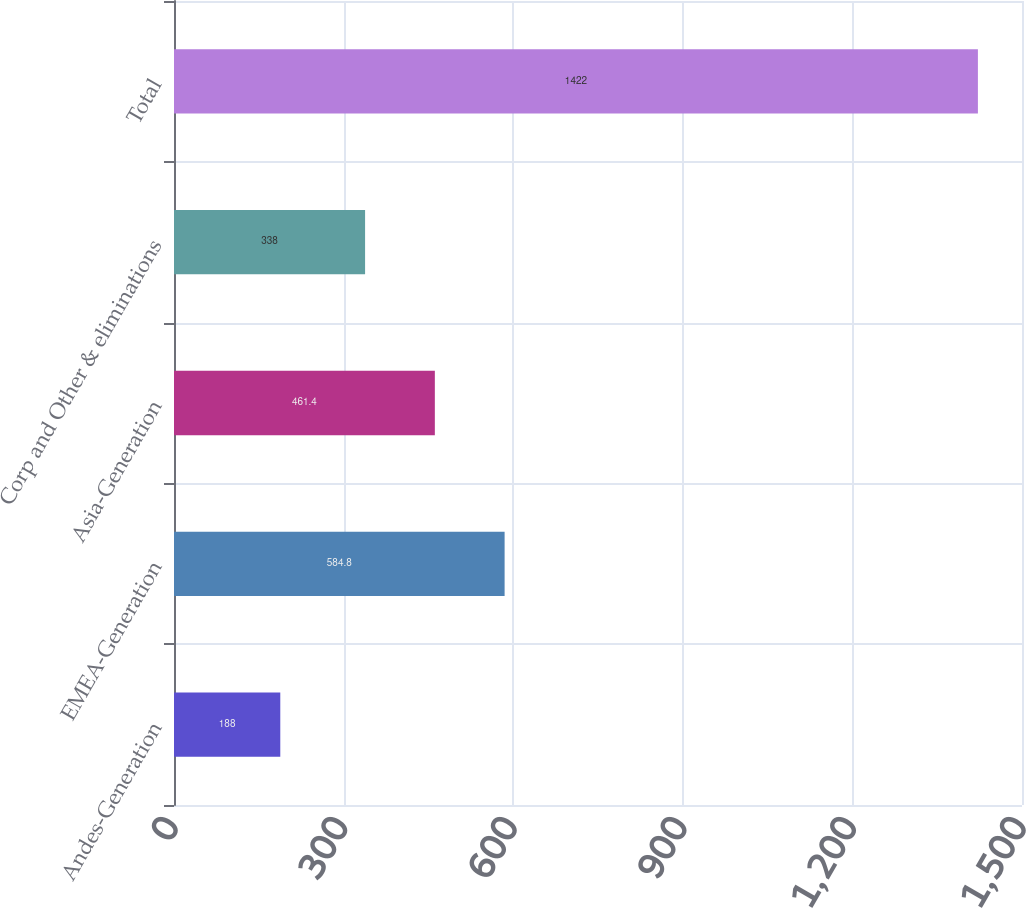Convert chart. <chart><loc_0><loc_0><loc_500><loc_500><bar_chart><fcel>Andes-Generation<fcel>EMEA-Generation<fcel>Asia-Generation<fcel>Corp and Other & eliminations<fcel>Total<nl><fcel>188<fcel>584.8<fcel>461.4<fcel>338<fcel>1422<nl></chart> 